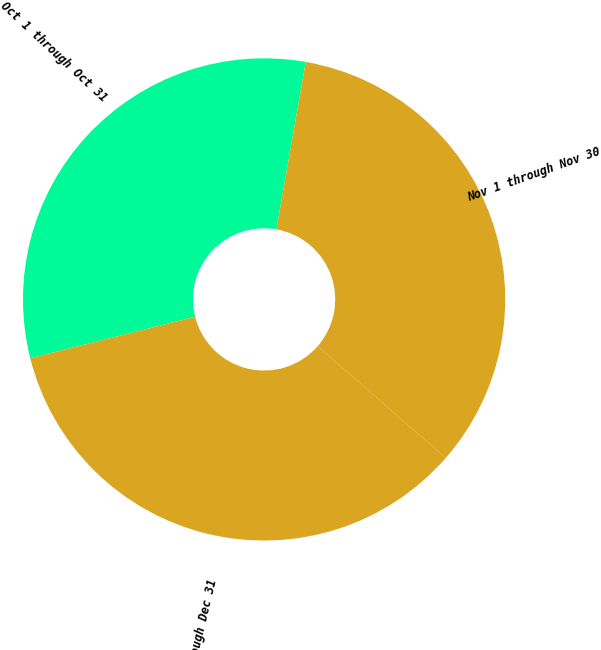Convert chart to OTSL. <chart><loc_0><loc_0><loc_500><loc_500><pie_chart><fcel>Oct 1 through Oct 31<fcel>Nov 1 through Nov 30<fcel>Dec 1 through Dec 31<nl><fcel>31.69%<fcel>33.66%<fcel>34.66%<nl></chart> 